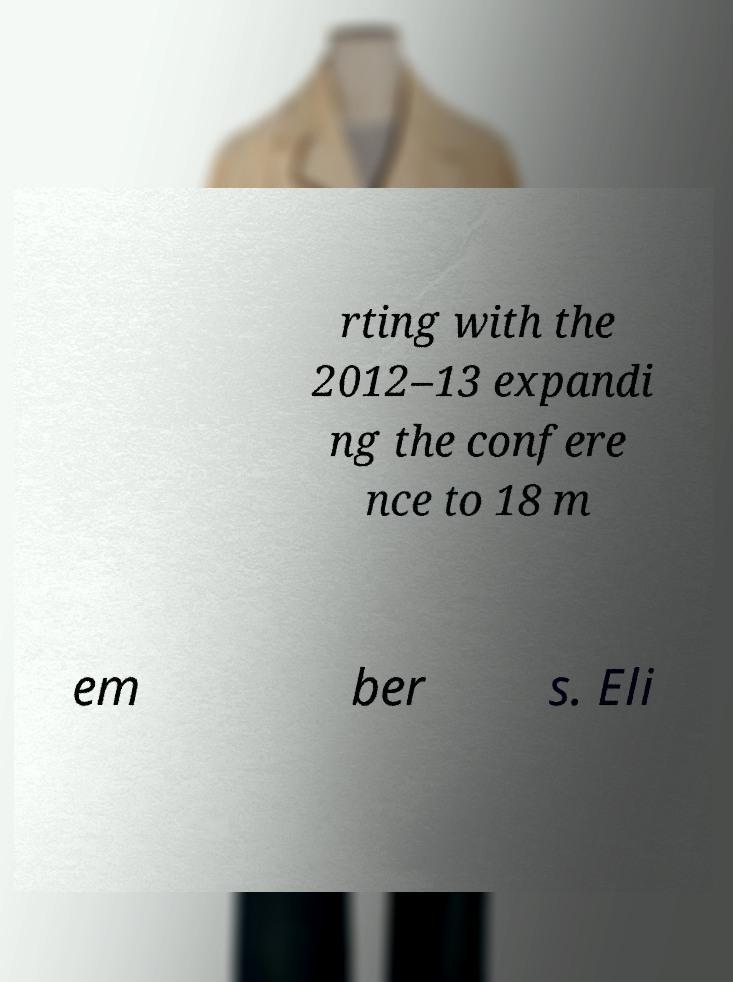Could you assist in decoding the text presented in this image and type it out clearly? rting with the 2012–13 expandi ng the confere nce to 18 m em ber s. Eli 